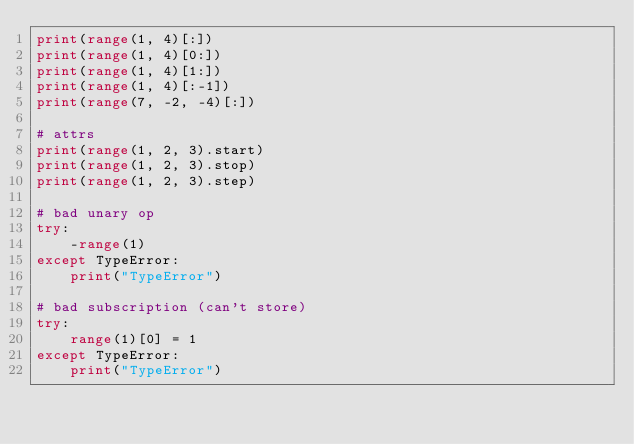<code> <loc_0><loc_0><loc_500><loc_500><_Python_>print(range(1, 4)[:])
print(range(1, 4)[0:])
print(range(1, 4)[1:])
print(range(1, 4)[:-1])
print(range(7, -2, -4)[:])

# attrs
print(range(1, 2, 3).start)
print(range(1, 2, 3).stop)
print(range(1, 2, 3).step)

# bad unary op
try:
    -range(1)
except TypeError:
    print("TypeError")

# bad subscription (can't store)
try:
    range(1)[0] = 1
except TypeError:
    print("TypeError")
</code> 